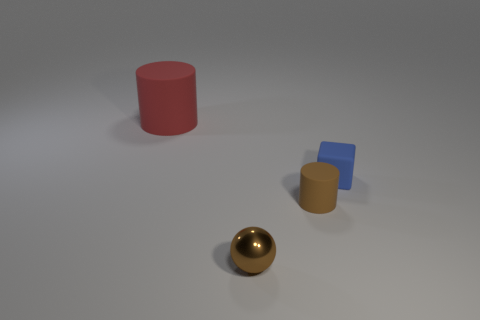Add 3 red rubber cylinders. How many objects exist? 7 Subtract all blocks. How many objects are left? 3 Subtract 2 cylinders. How many cylinders are left? 0 Subtract all red cylinders. How many cylinders are left? 1 Add 4 brown objects. How many brown objects exist? 6 Subtract 0 gray blocks. How many objects are left? 4 Subtract all purple blocks. Subtract all brown spheres. How many blocks are left? 1 Subtract all blue cylinders. How many cyan blocks are left? 0 Subtract all rubber cylinders. Subtract all blue matte spheres. How many objects are left? 2 Add 4 tiny blue rubber objects. How many tiny blue rubber objects are left? 5 